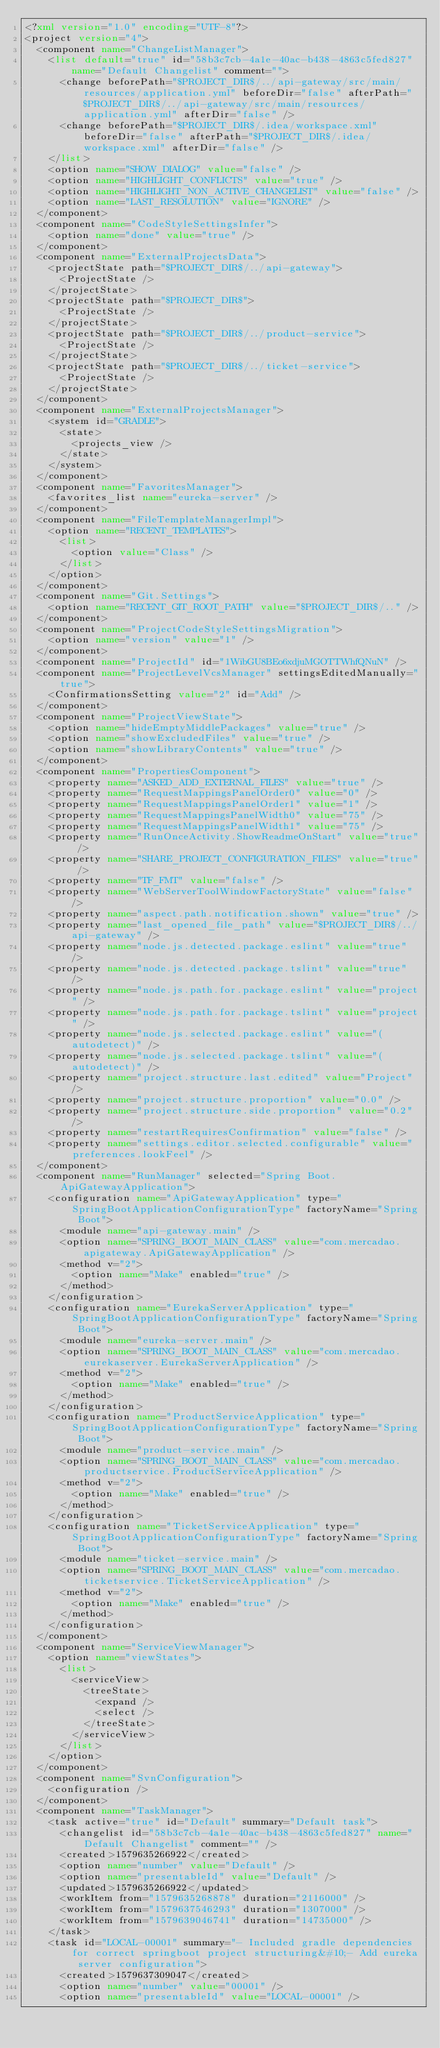Convert code to text. <code><loc_0><loc_0><loc_500><loc_500><_XML_><?xml version="1.0" encoding="UTF-8"?>
<project version="4">
  <component name="ChangeListManager">
    <list default="true" id="58b3c7cb-4a1e-40ac-b438-4863c5fed827" name="Default Changelist" comment="">
      <change beforePath="$PROJECT_DIR$/../api-gateway/src/main/resources/application.yml" beforeDir="false" afterPath="$PROJECT_DIR$/../api-gateway/src/main/resources/application.yml" afterDir="false" />
      <change beforePath="$PROJECT_DIR$/.idea/workspace.xml" beforeDir="false" afterPath="$PROJECT_DIR$/.idea/workspace.xml" afterDir="false" />
    </list>
    <option name="SHOW_DIALOG" value="false" />
    <option name="HIGHLIGHT_CONFLICTS" value="true" />
    <option name="HIGHLIGHT_NON_ACTIVE_CHANGELIST" value="false" />
    <option name="LAST_RESOLUTION" value="IGNORE" />
  </component>
  <component name="CodeStyleSettingsInfer">
    <option name="done" value="true" />
  </component>
  <component name="ExternalProjectsData">
    <projectState path="$PROJECT_DIR$/../api-gateway">
      <ProjectState />
    </projectState>
    <projectState path="$PROJECT_DIR$">
      <ProjectState />
    </projectState>
    <projectState path="$PROJECT_DIR$/../product-service">
      <ProjectState />
    </projectState>
    <projectState path="$PROJECT_DIR$/../ticket-service">
      <ProjectState />
    </projectState>
  </component>
  <component name="ExternalProjectsManager">
    <system id="GRADLE">
      <state>
        <projects_view />
      </state>
    </system>
  </component>
  <component name="FavoritesManager">
    <favorites_list name="eureka-server" />
  </component>
  <component name="FileTemplateManagerImpl">
    <option name="RECENT_TEMPLATES">
      <list>
        <option value="Class" />
      </list>
    </option>
  </component>
  <component name="Git.Settings">
    <option name="RECENT_GIT_ROOT_PATH" value="$PROJECT_DIR$/.." />
  </component>
  <component name="ProjectCodeStyleSettingsMigration">
    <option name="version" value="1" />
  </component>
  <component name="ProjectId" id="1WibGU8BEo6xdjuMGOTTWhfQNuN" />
  <component name="ProjectLevelVcsManager" settingsEditedManually="true">
    <ConfirmationsSetting value="2" id="Add" />
  </component>
  <component name="ProjectViewState">
    <option name="hideEmptyMiddlePackages" value="true" />
    <option name="showExcludedFiles" value="true" />
    <option name="showLibraryContents" value="true" />
  </component>
  <component name="PropertiesComponent">
    <property name="ASKED_ADD_EXTERNAL_FILES" value="true" />
    <property name="RequestMappingsPanelOrder0" value="0" />
    <property name="RequestMappingsPanelOrder1" value="1" />
    <property name="RequestMappingsPanelWidth0" value="75" />
    <property name="RequestMappingsPanelWidth1" value="75" />
    <property name="RunOnceActivity.ShowReadmeOnStart" value="true" />
    <property name="SHARE_PROJECT_CONFIGURATION_FILES" value="true" />
    <property name="TF_FMT" value="false" />
    <property name="WebServerToolWindowFactoryState" value="false" />
    <property name="aspect.path.notification.shown" value="true" />
    <property name="last_opened_file_path" value="$PROJECT_DIR$/../api-gateway" />
    <property name="node.js.detected.package.eslint" value="true" />
    <property name="node.js.detected.package.tslint" value="true" />
    <property name="node.js.path.for.package.eslint" value="project" />
    <property name="node.js.path.for.package.tslint" value="project" />
    <property name="node.js.selected.package.eslint" value="(autodetect)" />
    <property name="node.js.selected.package.tslint" value="(autodetect)" />
    <property name="project.structure.last.edited" value="Project" />
    <property name="project.structure.proportion" value="0.0" />
    <property name="project.structure.side.proportion" value="0.2" />
    <property name="restartRequiresConfirmation" value="false" />
    <property name="settings.editor.selected.configurable" value="preferences.lookFeel" />
  </component>
  <component name="RunManager" selected="Spring Boot.ApiGatewayApplication">
    <configuration name="ApiGatewayApplication" type="SpringBootApplicationConfigurationType" factoryName="Spring Boot">
      <module name="api-gateway.main" />
      <option name="SPRING_BOOT_MAIN_CLASS" value="com.mercadao.apigateway.ApiGatewayApplication" />
      <method v="2">
        <option name="Make" enabled="true" />
      </method>
    </configuration>
    <configuration name="EurekaServerApplication" type="SpringBootApplicationConfigurationType" factoryName="Spring Boot">
      <module name="eureka-server.main" />
      <option name="SPRING_BOOT_MAIN_CLASS" value="com.mercadao.eurekaserver.EurekaServerApplication" />
      <method v="2">
        <option name="Make" enabled="true" />
      </method>
    </configuration>
    <configuration name="ProductServiceApplication" type="SpringBootApplicationConfigurationType" factoryName="Spring Boot">
      <module name="product-service.main" />
      <option name="SPRING_BOOT_MAIN_CLASS" value="com.mercadao.productservice.ProductServiceApplication" />
      <method v="2">
        <option name="Make" enabled="true" />
      </method>
    </configuration>
    <configuration name="TicketServiceApplication" type="SpringBootApplicationConfigurationType" factoryName="Spring Boot">
      <module name="ticket-service.main" />
      <option name="SPRING_BOOT_MAIN_CLASS" value="com.mercadao.ticketservice.TicketServiceApplication" />
      <method v="2">
        <option name="Make" enabled="true" />
      </method>
    </configuration>
  </component>
  <component name="ServiceViewManager">
    <option name="viewStates">
      <list>
        <serviceView>
          <treeState>
            <expand />
            <select />
          </treeState>
        </serviceView>
      </list>
    </option>
  </component>
  <component name="SvnConfiguration">
    <configuration />
  </component>
  <component name="TaskManager">
    <task active="true" id="Default" summary="Default task">
      <changelist id="58b3c7cb-4a1e-40ac-b438-4863c5fed827" name="Default Changelist" comment="" />
      <created>1579635266922</created>
      <option name="number" value="Default" />
      <option name="presentableId" value="Default" />
      <updated>1579635266922</updated>
      <workItem from="1579635268878" duration="2116000" />
      <workItem from="1579637546293" duration="1307000" />
      <workItem from="1579639046741" duration="14735000" />
    </task>
    <task id="LOCAL-00001" summary="- Included gradle dependencies for correct springboot project structuring&#10;- Add eureka server configuration">
      <created>1579637309047</created>
      <option name="number" value="00001" />
      <option name="presentableId" value="LOCAL-00001" /></code> 